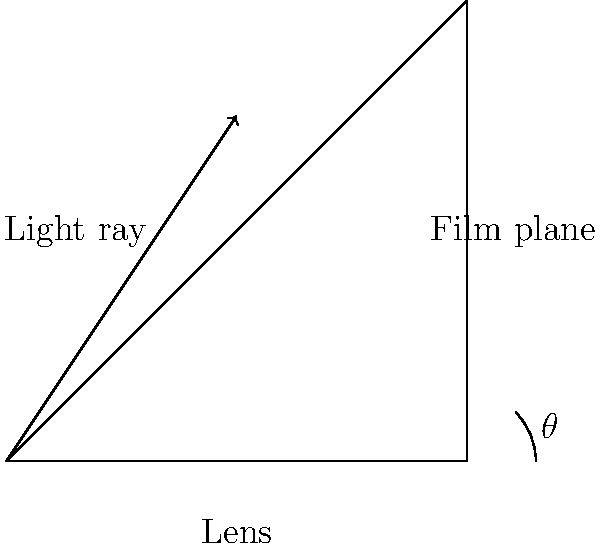In film photography, how does the angle $\theta$ of incident light entering a camera lens affect the exposure on the film plane, assuming all other factors remain constant? To understand the effect of the incident light angle on exposure, let's break it down step-by-step:

1. The intensity of light reaching the film plane is proportional to the cosine of the angle of incidence ($\theta$). This relationship is known as Lambert's Cosine Law.

2. The exposure (E) on the film plane can be expressed mathematically as:

   $E \propto I \cos{\theta}$

   Where $I$ is the intensity of the incident light.

3. As the angle $\theta$ increases from 0° (perpendicular to the film plane) to larger angles:
   - $\cos{\theta}$ decreases
   - The effective area of the film exposed to light increases

4. The decrease in $\cos{\theta}$ has a more significant effect than the increase in the exposed area.

5. Therefore, as $\theta$ increases:
   - Less light reaches the film plane
   - The exposure decreases

6. This effect is most noticeable at the edges of wide-angle lenses or in large format cameras, where the angle of incidence can be quite large at the corners of the frame.

7. In practice, this phenomenon contributes to vignetting, where the corners of a photograph appear darker than the center.
Answer: As $\theta$ increases, exposure decreases due to Lambert's Cosine Law. 